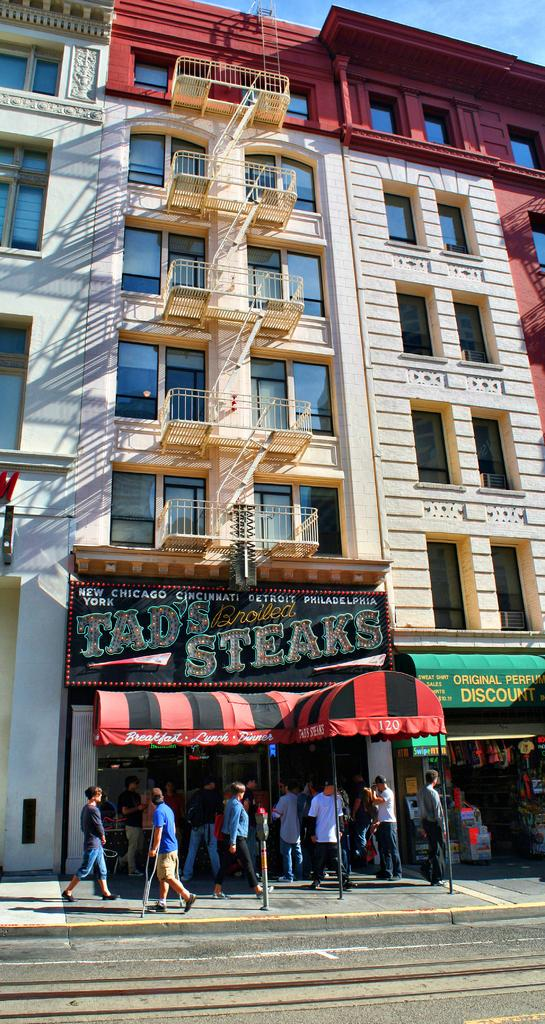What type of structures are visible in the image? There are buildings with windows in the image. What can be seen on the buildings? There are name boards on the buildings. What are the people in the image doing? There is a group of people walking on a pathway. What type of transportation route is present in the image? There is a road in the image. What temporary shelter is visible in the image? There is a tent in the image. What type of music is the band playing in the image? There is no band present in the image, so it is not possible to determine what type of music they might be playing. 